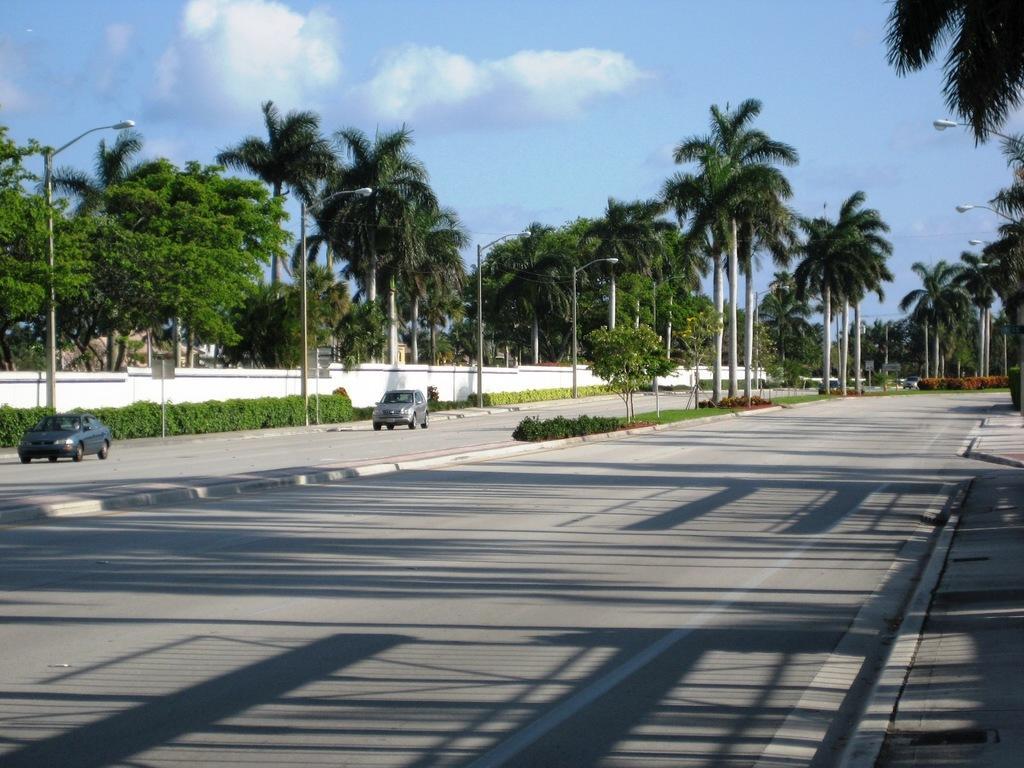Please provide a concise description of this image. This image is clicked on a road. To the left, there is a car. In the background, there are trees and plants. 